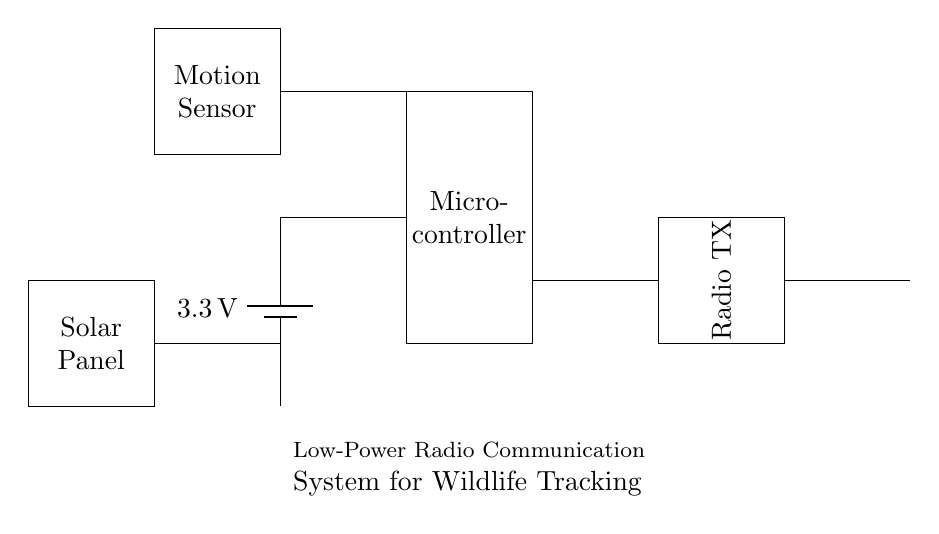What is the voltage of the battery in this circuit? The battery is labeled with a voltage of 3.3 volts, which indicates the potential difference it provides to the circuit.
Answer: 3.3 volts What component controls the communication in this system? The component responsible for communication is the radio transmitter, which is indicated in the diagram as "Radio TX."
Answer: Radio transmitter How many main components are used in this circuit? By counting the distinct components shown (battery, microcontroller, radio transmitter, antenna, motion sensor, solar panel), we find that there are six main components in the circuit.
Answer: Six What is the function of the motion sensor in this circuit? The motion sensor's role is to detect movement, which it relays to the microcontroller for processing, indicating that it is used for tracking wildlife movements.
Answer: Detect movement What is the purpose of the solar panel in this circuit? The solar panel provides renewable energy to power the circuit, allowing for sustainable functionality in wildlife tracking without needing to replace batteries frequently.
Answer: Supply energy What connects the microcontroller to the radio transmitter? The connection is made through a wire that runs between the microcontroller and the radio transmitter, highlighting the communication line used for data transmission.
Answer: Wire connection Which component is responsible for capturing environmental energy in this system? The solar panel is responsible for capturing environmental energy, converting sunlight into electrical energy to support the circuit's function.
Answer: Solar panel 